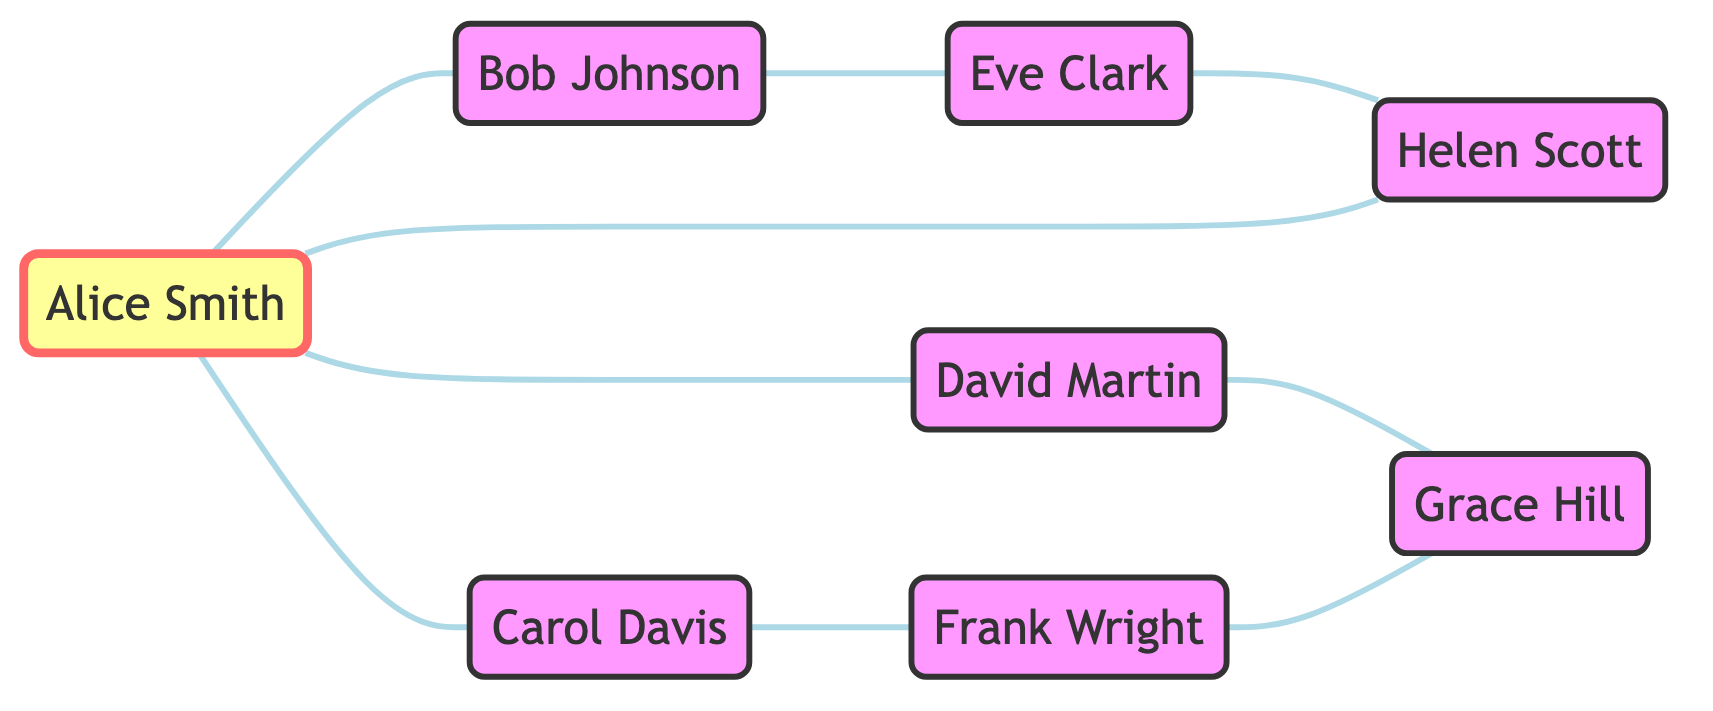What is the total number of nodes in the diagram? The diagram lists 8 distinct individuals involved in volcano-related studies, represented as nodes. Counting each mentioned node gives a total of 8.
Answer: 8 What is the connection between Alice Smith and David Martin? According to the edges in the graph, Alice Smith is directly connected to David Martin, indicating a direct relationship between them.
Answer: Direct connection Which volcanologist has the most connections? By examining the nodes, Alice Smith is connected to three other nodes: Bob Johnson, Carol Davis, and David Martin, making her the volcanologist with the most connections.
Answer: Alice Smith How many edges are connected to Frank Wright? Frank Wright has two edges connected to him: one to Carol Davis and the other to Grace Hill, which can be counted directly from the diagram.
Answer: 2 Who is connected to Helen Scott? Helen Scott has one direct connection from Eve Clark and one from Alice Smith, making both Alice and Eve connected to her directly. Thus, she has two noted connections.
Answer: Alice Smith and Eve Clark What is the path from Alice Smith to Grace Hill? To find a path from Alice Smith to Grace Hill, we trace the connections: Alice Smith connects to David Martin, who then connects to Grace Hill. Therefore, the path is Alice Smith → David Martin → Grace Hill.
Answer: Alice Smith → David Martin → Grace Hill Is there a cycle in the graph involving Helen Scott? A cycle occurs when you can return to a starting node without retracing any edge. Starting from Helen Scott, we can go to Alice Smith and then back to Helen Scott, confirming the presence of a cycle.
Answer: Yes List all volcanologists who have connections to both Alice Smith and Grace Hill. Upon examining the edges, the only volcanologist that connects to both Alice Smith and Grace Hill is David Martin, who connects to Alice Smith directly and to Grace Hill as well.
Answer: David Martin 